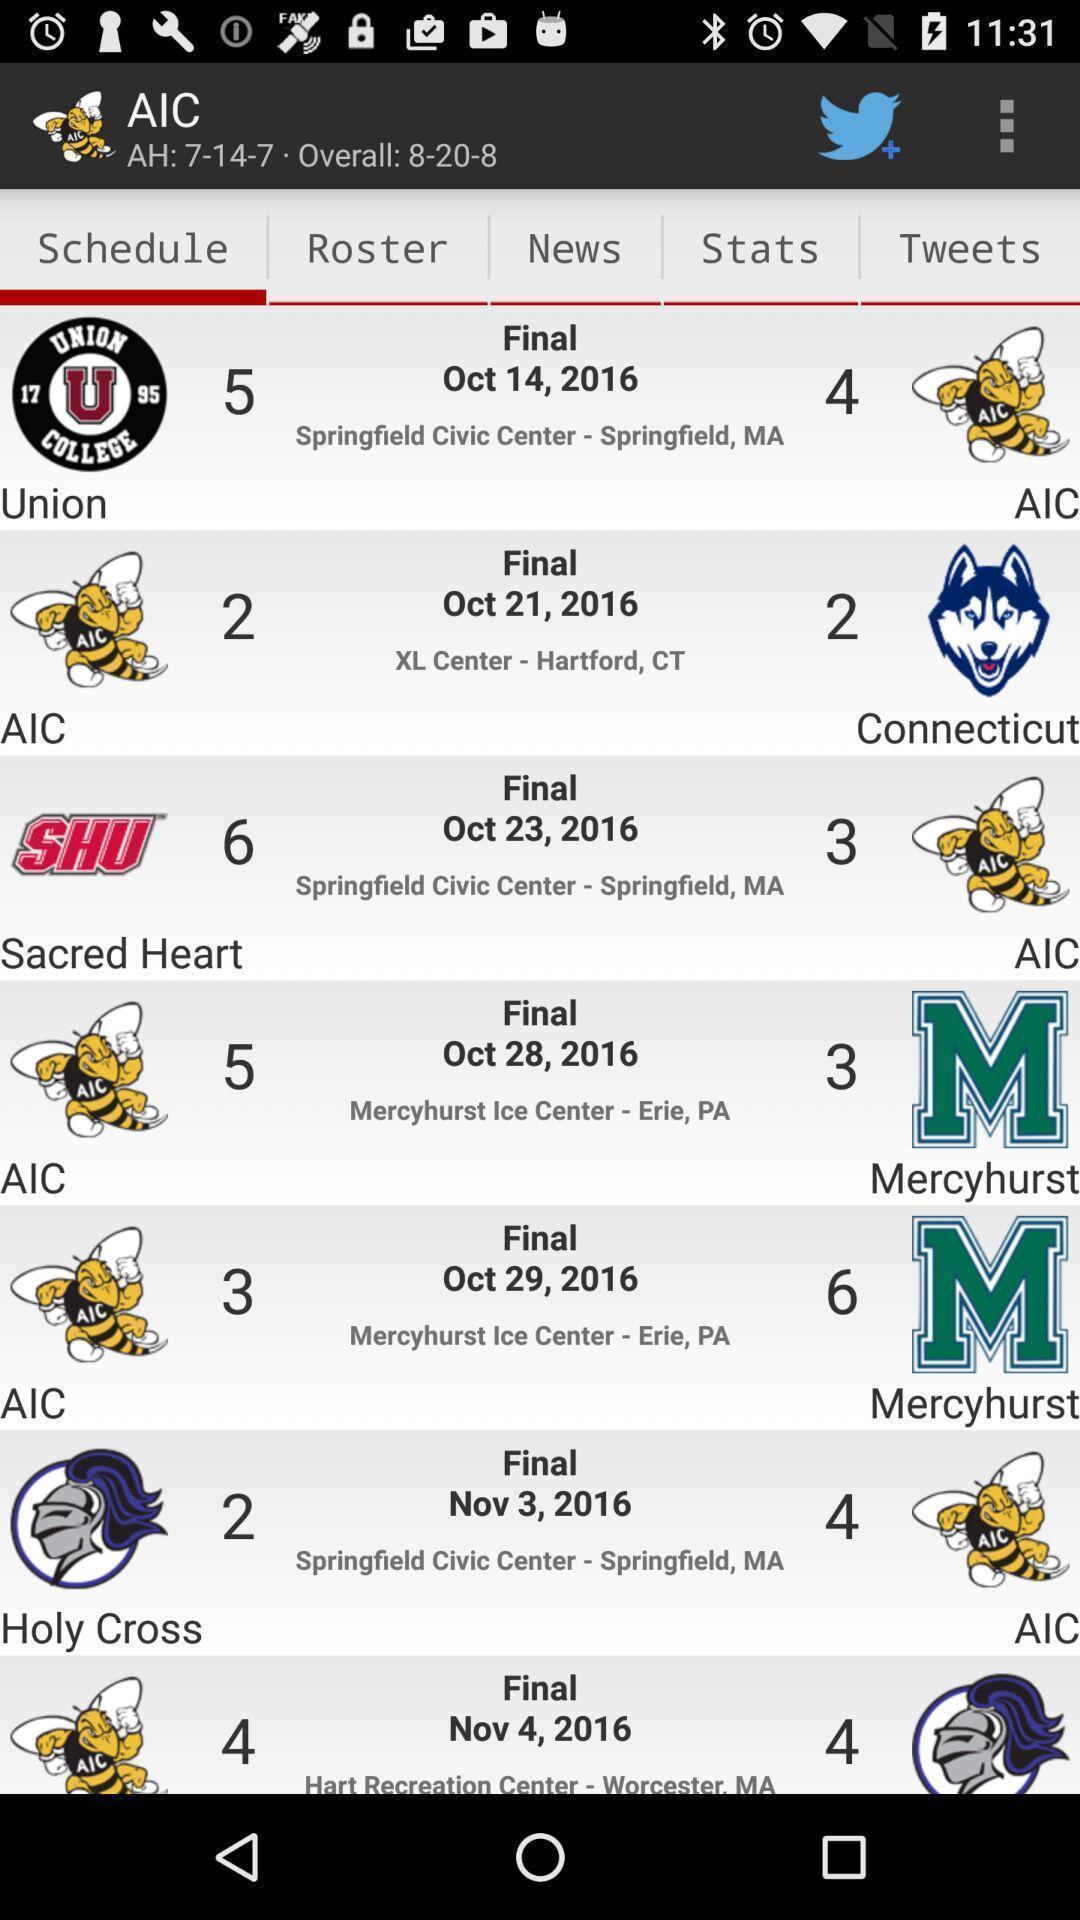Describe the key features of this screenshot. Screen shows schedules of matches. 